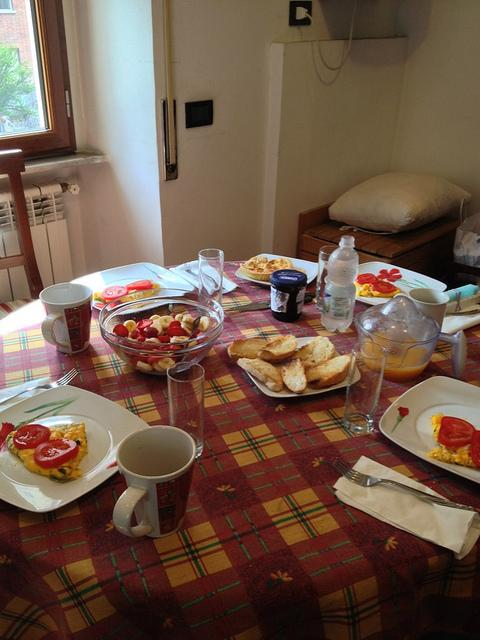What will they serve to drink?

Choices:
A) orange juice
B) milk
C) wine
D) grape juice orange juice 